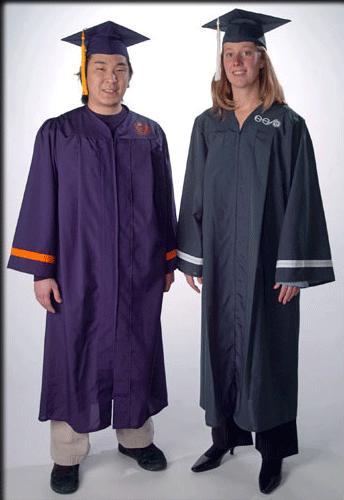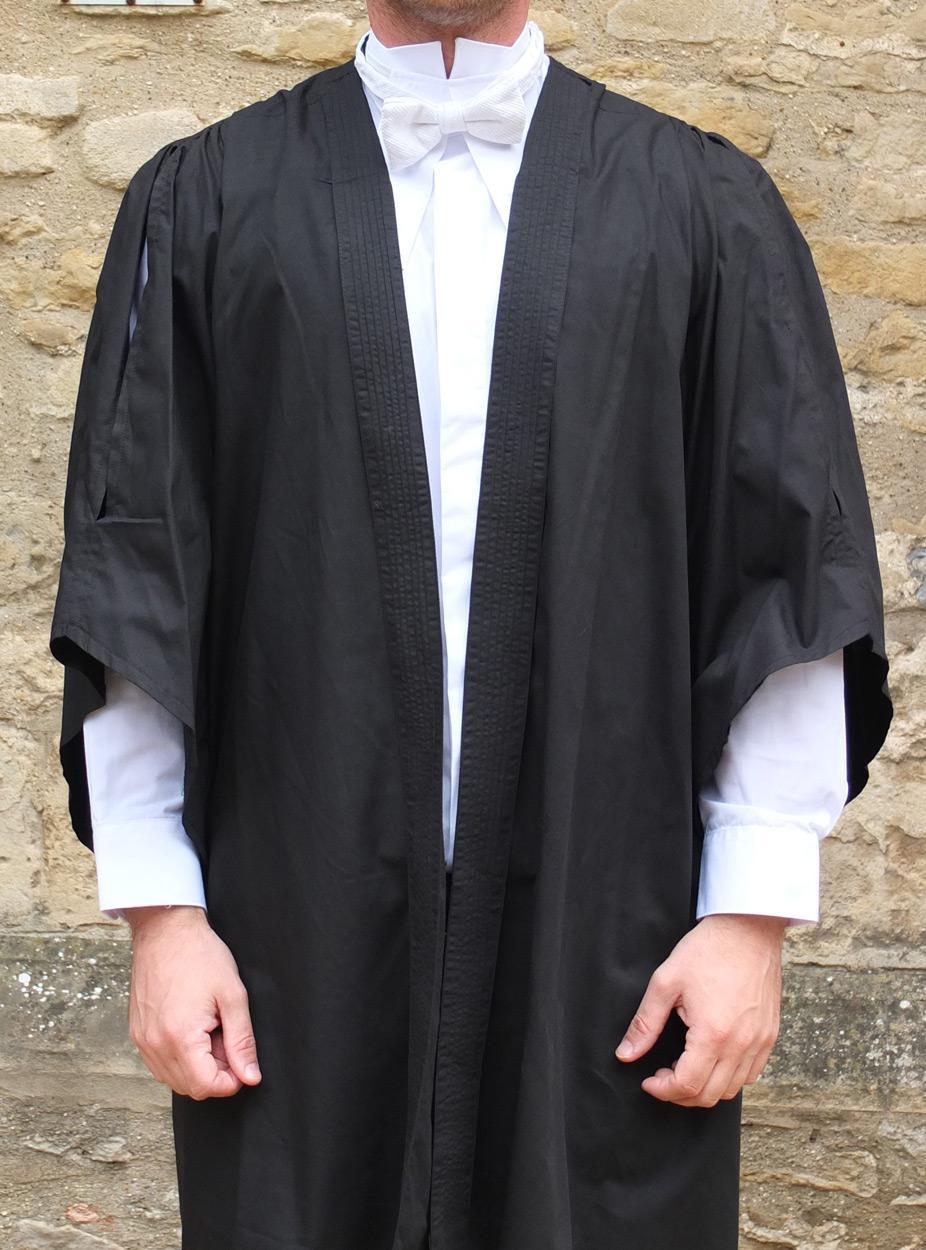The first image is the image on the left, the second image is the image on the right. For the images displayed, is the sentence "One picture shows someone from the back side." factually correct? Answer yes or no. No. The first image is the image on the left, the second image is the image on the right. Considering the images on both sides, is "a person is facing away from the camera with a light colored sash hanging down their back" valid? Answer yes or no. No. 